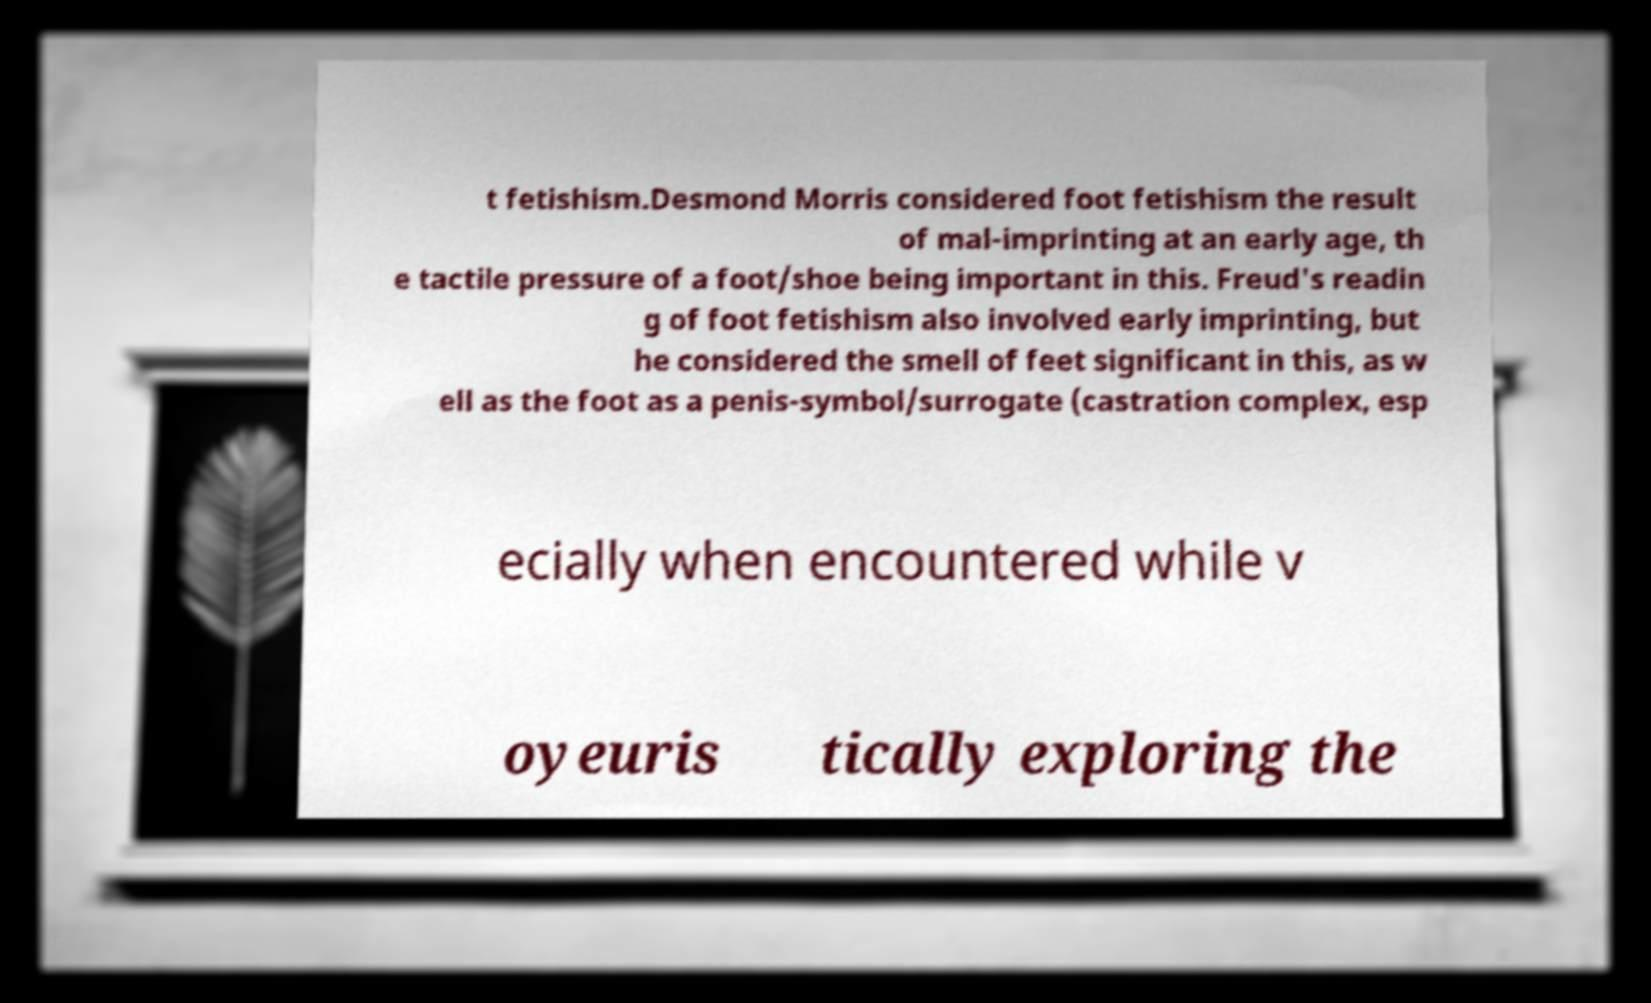There's text embedded in this image that I need extracted. Can you transcribe it verbatim? t fetishism.Desmond Morris considered foot fetishism the result of mal-imprinting at an early age, th e tactile pressure of a foot/shoe being important in this. Freud's readin g of foot fetishism also involved early imprinting, but he considered the smell of feet significant in this, as w ell as the foot as a penis-symbol/surrogate (castration complex, esp ecially when encountered while v oyeuris tically exploring the 